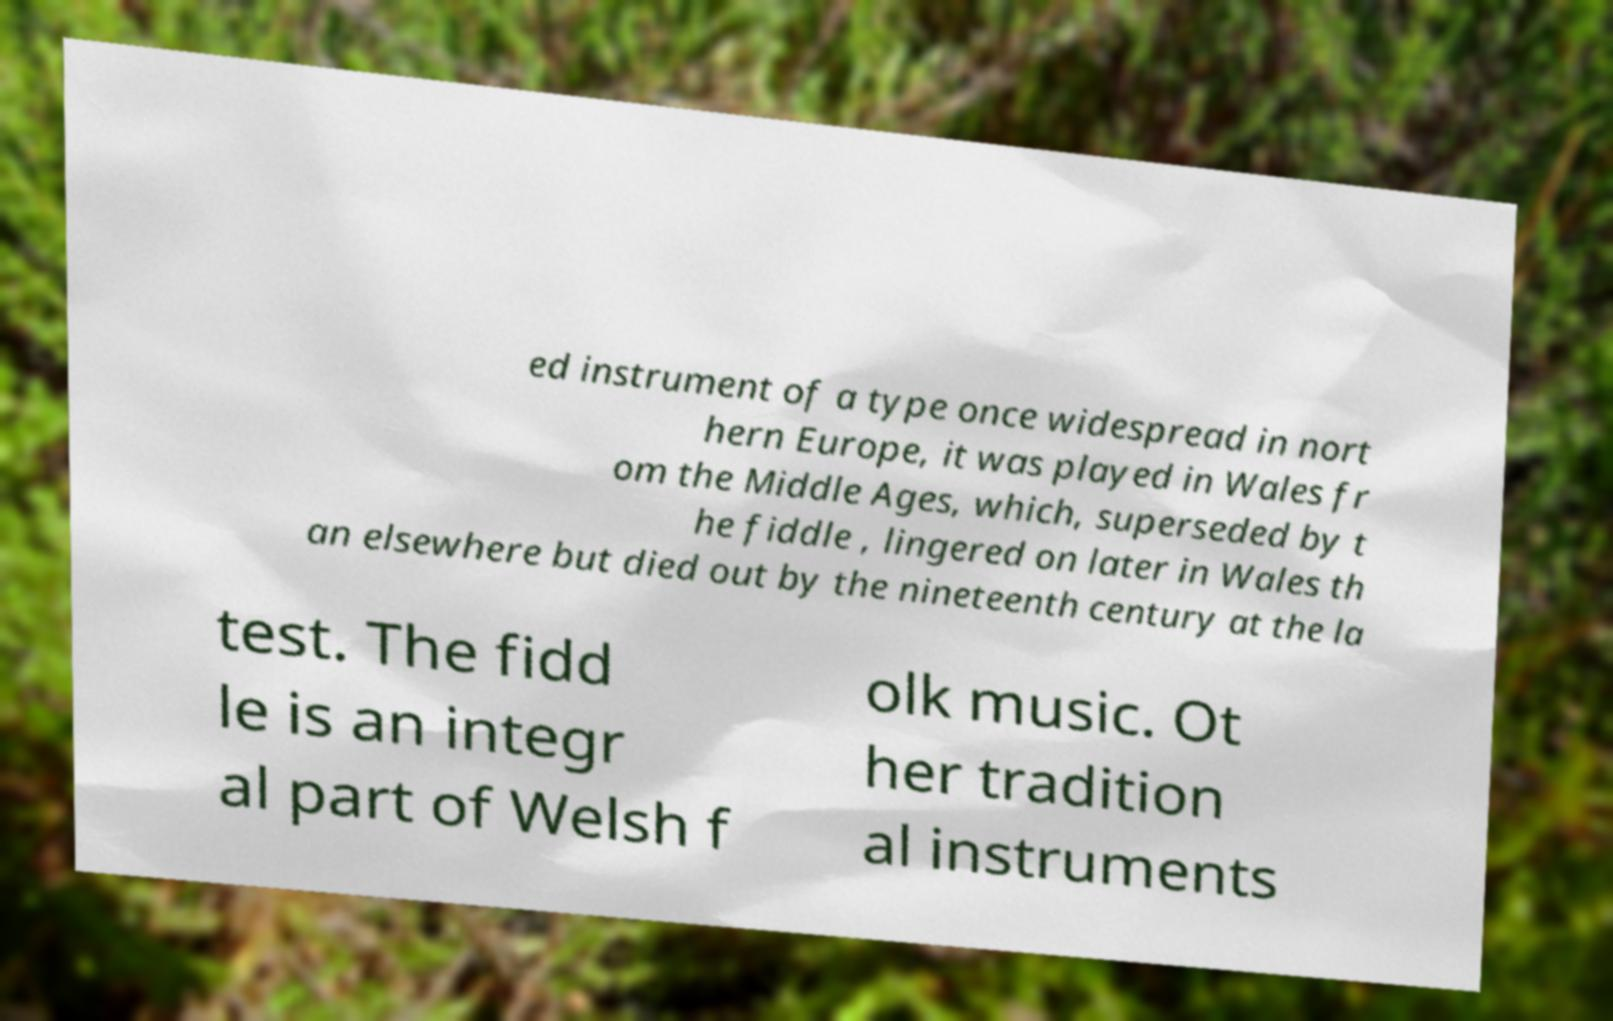For documentation purposes, I need the text within this image transcribed. Could you provide that? ed instrument of a type once widespread in nort hern Europe, it was played in Wales fr om the Middle Ages, which, superseded by t he fiddle , lingered on later in Wales th an elsewhere but died out by the nineteenth century at the la test. The fidd le is an integr al part of Welsh f olk music. Ot her tradition al instruments 